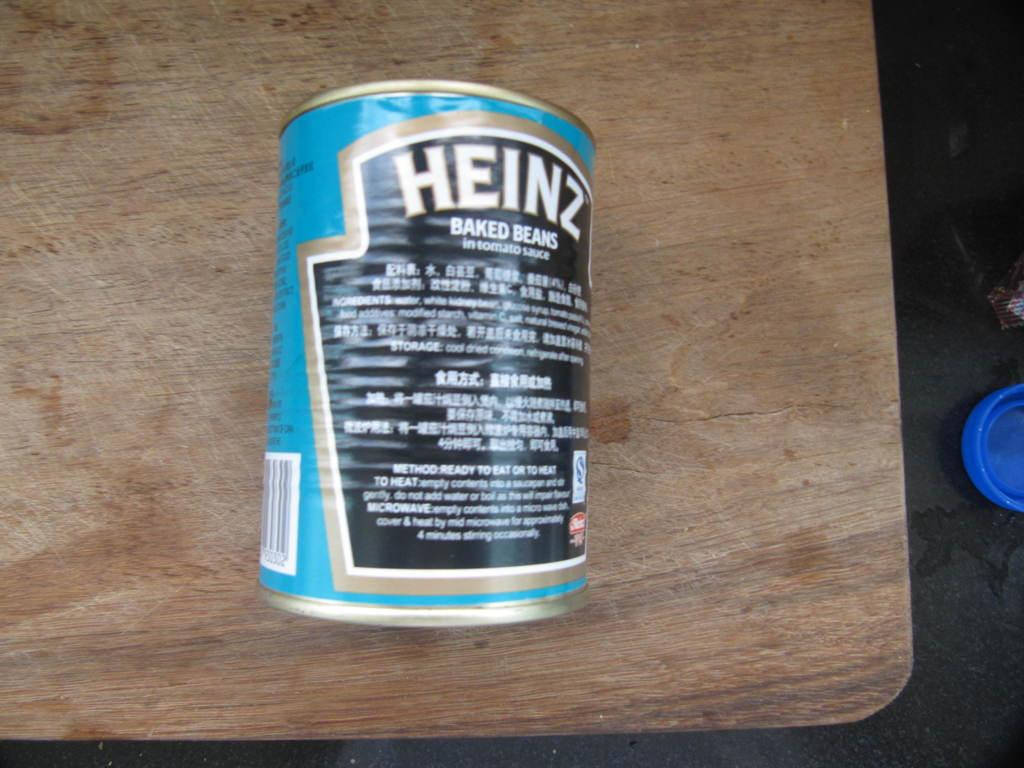<image>
Render a clear and concise summary of the photo. A blue can of food on a wooden table says Heinz baked beans. 